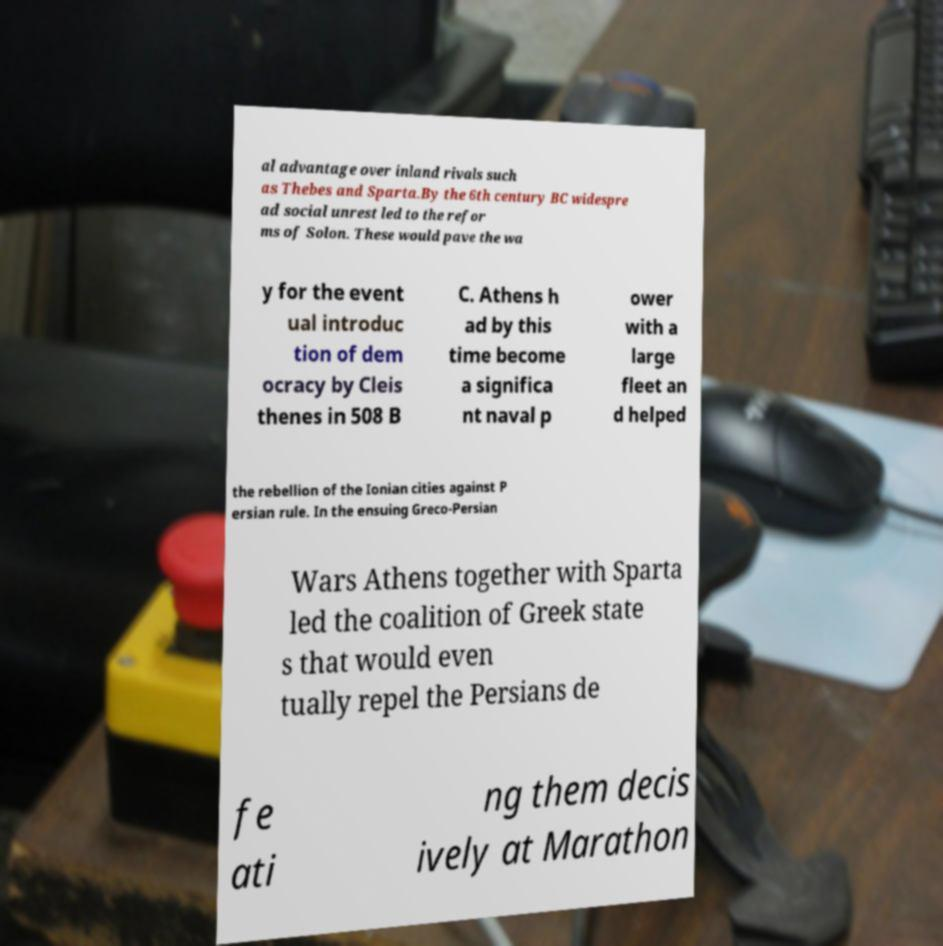There's text embedded in this image that I need extracted. Can you transcribe it verbatim? al advantage over inland rivals such as Thebes and Sparta.By the 6th century BC widespre ad social unrest led to the refor ms of Solon. These would pave the wa y for the event ual introduc tion of dem ocracy by Cleis thenes in 508 B C. Athens h ad by this time become a significa nt naval p ower with a large fleet an d helped the rebellion of the Ionian cities against P ersian rule. In the ensuing Greco-Persian Wars Athens together with Sparta led the coalition of Greek state s that would even tually repel the Persians de fe ati ng them decis ively at Marathon 